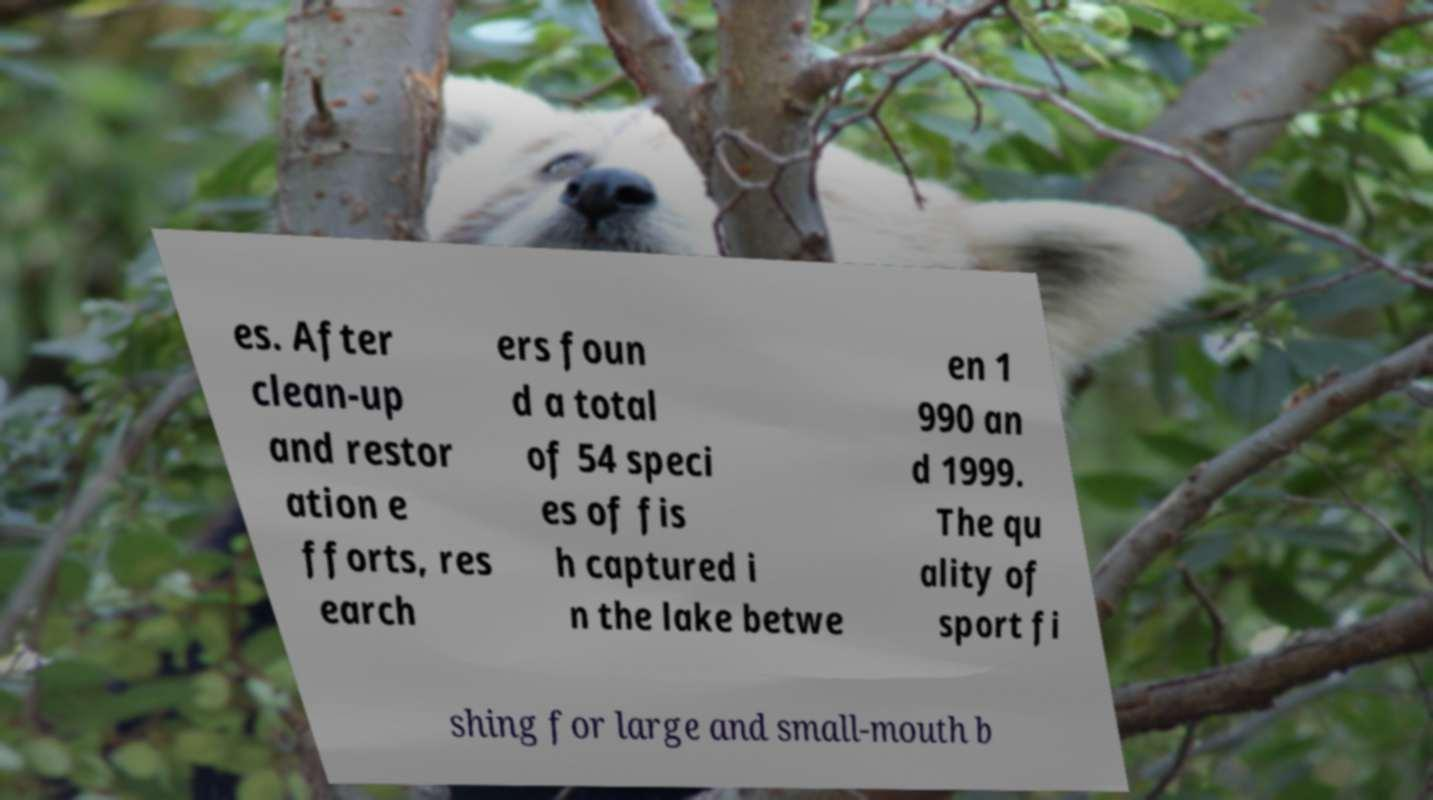Could you extract and type out the text from this image? es. After clean-up and restor ation e fforts, res earch ers foun d a total of 54 speci es of fis h captured i n the lake betwe en 1 990 an d 1999. The qu ality of sport fi shing for large and small-mouth b 